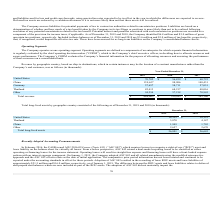According to Acacia Communications's financial document, What are operating segments? Operating segments are defined as components of an enterprise for which separate financial information is regularly evaluated by the chief operating decision maker (“CODM”), which is the Company’s chief executive officer, in deciding how to allocate resources and assess performance.. The document states: "The Company operates as one operating segment. Operating segments are defined as components of an enterprise for which separate financial information ..." Also, Who evaluates the Company's financial information for the purpose of resource allocation and performance assessment? The document shows two values: The Company’s CODM and chief operating decision maker (“CODM”). From the document: "how to allocate resources and assess performance. The Company’s CODM evaluates the Company’s financial information for the purpose of allocating resou..." Also, What is revenue by geographic country based on? ship-to destinations. The document states: "Revenue by geographic country, based on ship-to destinations, which in certain instances may be the location of a contract manufacturer rather than th..." Also, can you calculate: What is the proportion of revenue by US in the total revenue in 2019?  Based on the calculation: 70,702/464,663, the result is 0.15. This is based on the information: "United States $ 70,702 $ 56,839 $ 60,723 Total revenue $ 464,663 $ 339,891 $ 385,166..." The key data points involved are: 464,663, 70,702. Also, can you calculate: What is the percentage increase in revenue by China from 2018 to 2019? To answer this question, I need to perform calculations using the financial data. The calculation is: (159,637-98,906)/98,906, which equals 61.4 (percentage). This is based on the information: "China 159,637 98,906 148,431 China 159,637 98,906 148,431..." The key data points involved are: 159,637, 98,906. Also, can you calculate: What is the total revenue in Thailand between 2017 to 2019? Based on the calculation: 82,413+68,217+48,016, the result is 198646 (in thousands). This is based on the information: "Thailand 82,413 68,217 48,016 Thailand 82,413 68,217 48,016 Thailand 82,413 68,217 48,016..." The key data points involved are: 48,016, 68,217, 82,413. 